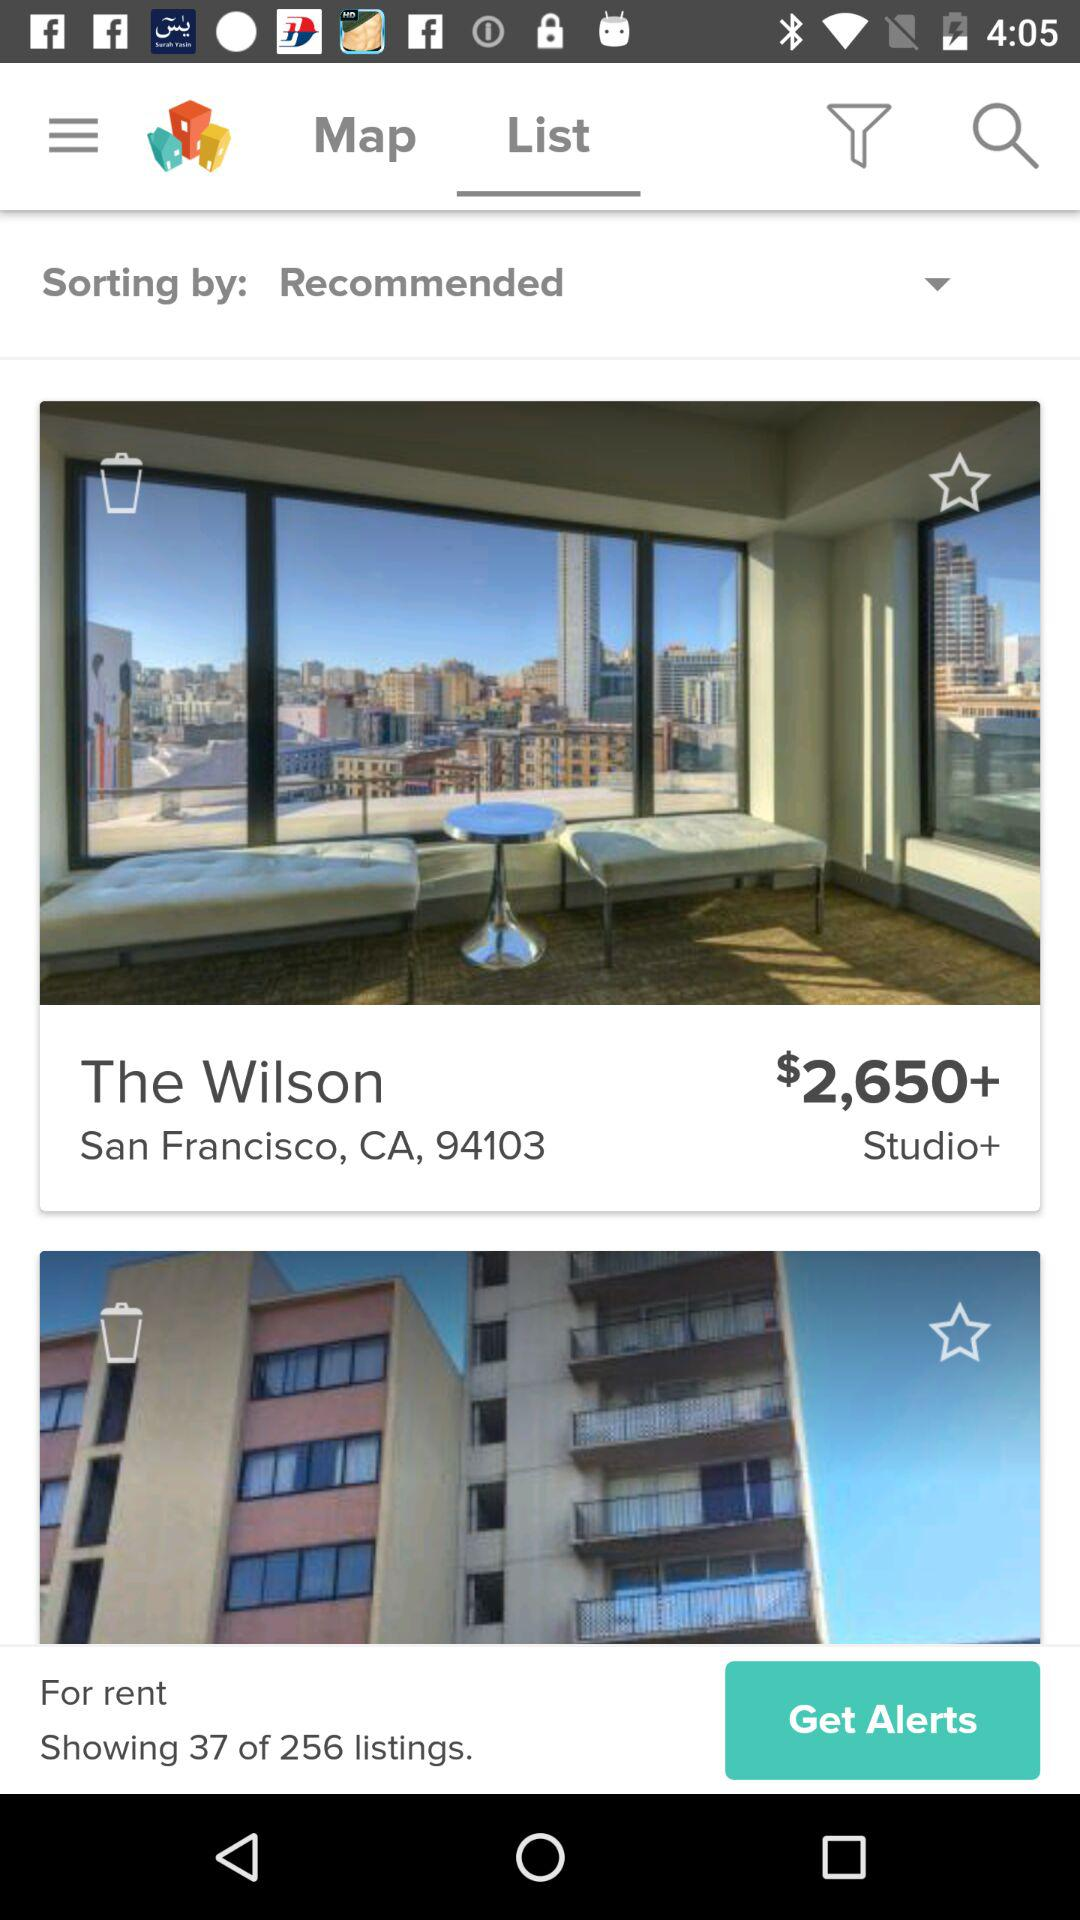What is the price of the room in "The Wilson"? The price of the room in "The Wilson" is more than $2,650. 